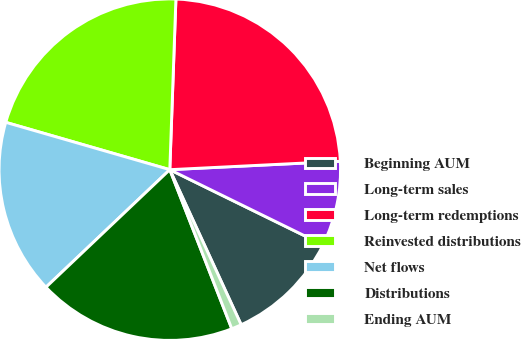Convert chart to OTSL. <chart><loc_0><loc_0><loc_500><loc_500><pie_chart><fcel>Beginning AUM<fcel>Long-term sales<fcel>Long-term redemptions<fcel>Reinvested distributions<fcel>Net flows<fcel>Distributions<fcel>Ending AUM<nl><fcel>10.88%<fcel>8.04%<fcel>23.65%<fcel>21.1%<fcel>16.56%<fcel>18.83%<fcel>0.95%<nl></chart> 